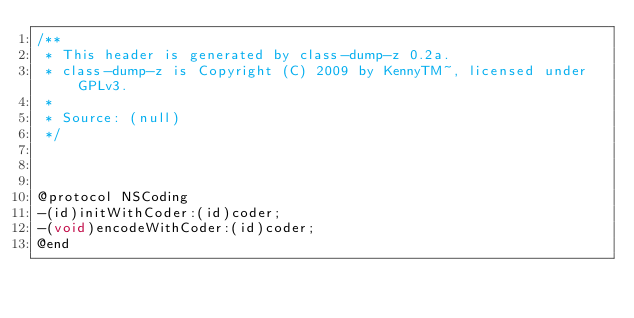Convert code to text. <code><loc_0><loc_0><loc_500><loc_500><_C_>/**
 * This header is generated by class-dump-z 0.2a.
 * class-dump-z is Copyright (C) 2009 by KennyTM~, licensed under GPLv3.
 *
 * Source: (null)
 */



@protocol NSCoding
-(id)initWithCoder:(id)coder;
-(void)encodeWithCoder:(id)coder;
@end

</code> 